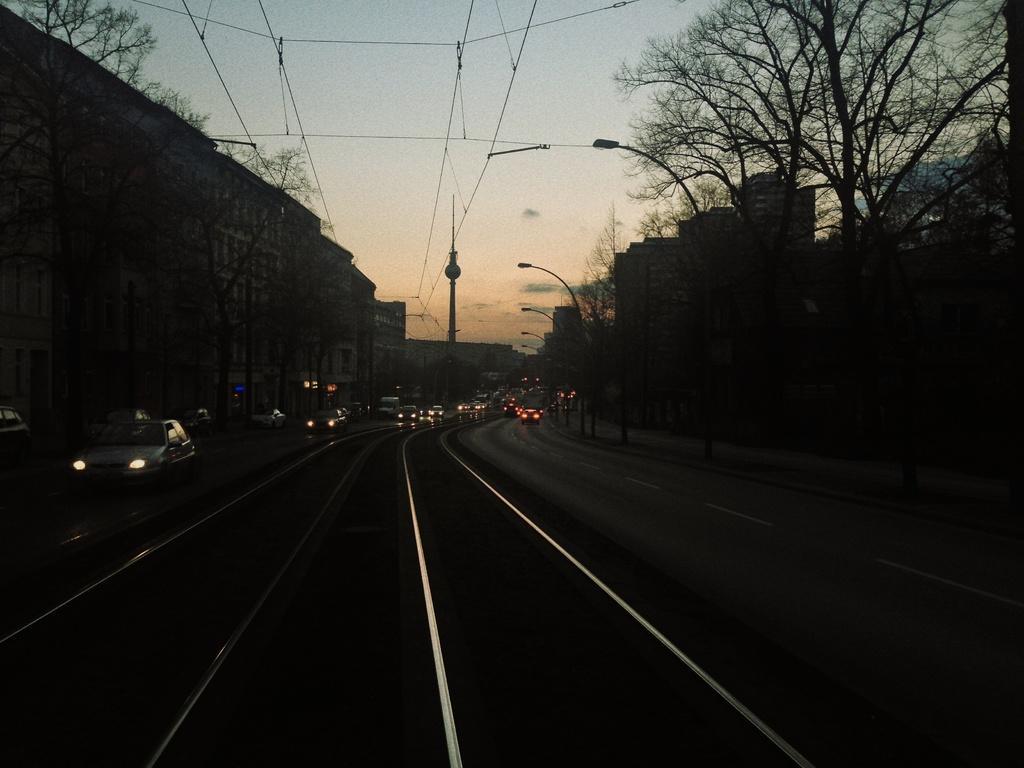In one or two sentences, can you explain what this image depicts? This image is taken on a road. On the left side there are cars running on the road and there are buildings, trees. In the background there are buildings, poles, wires. On the right side there are street light poles, buildings, and dry trees. 